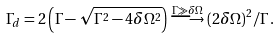Convert formula to latex. <formula><loc_0><loc_0><loc_500><loc_500>\Gamma _ { d } = 2 \left ( \Gamma - \sqrt { \Gamma ^ { 2 } - 4 \delta \Omega ^ { 2 } } \right ) \stackrel { \Gamma \gg \delta \Omega } { \longrightarrow } ( 2 \delta \Omega ) ^ { 2 } / \Gamma \, .</formula> 